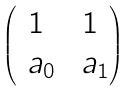<formula> <loc_0><loc_0><loc_500><loc_500>\begin{pmatrix} 1 & 1 \\ \ a _ { 0 } & \ a _ { 1 } \end{pmatrix}</formula> 